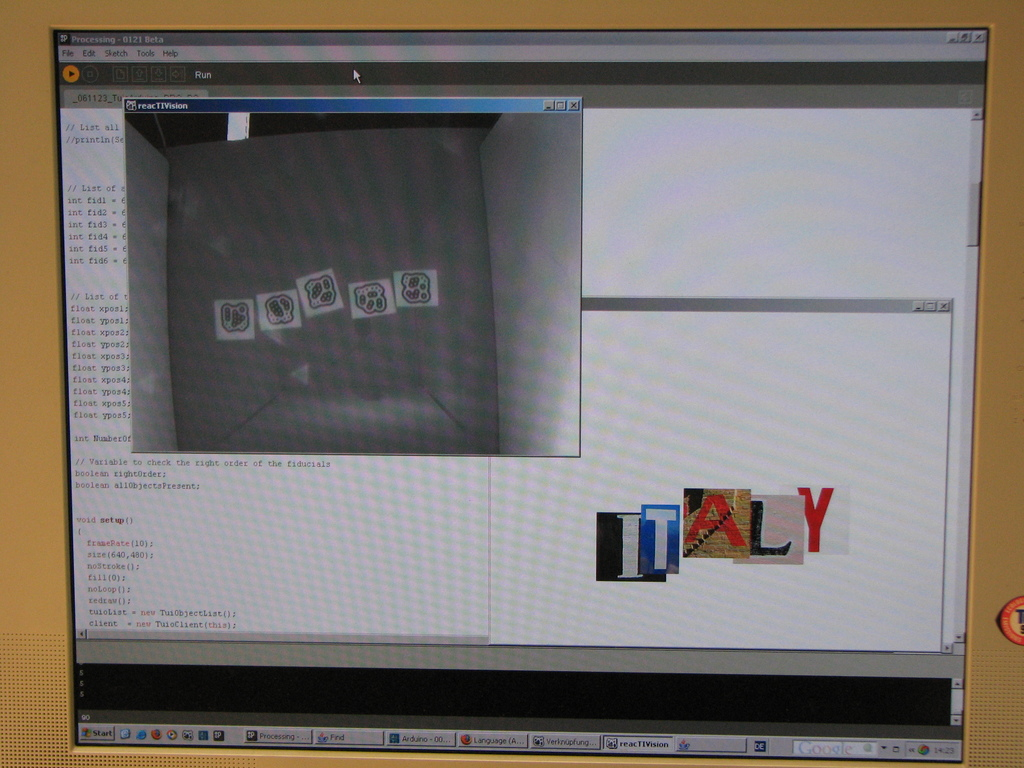Provide a one-sentence caption for the provided image. The image shows a computer screen running the 'reacTIVision' software, displaying numerous fiducial markers on a grey grid, alongside a graphics editing window creatively forming the word ITALY with images of landmarks and the Italian flag. 